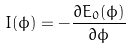<formula> <loc_0><loc_0><loc_500><loc_500>I ( \phi ) = - \frac { \partial { E _ { 0 } ( \phi ) } } { \partial { \phi } }</formula> 